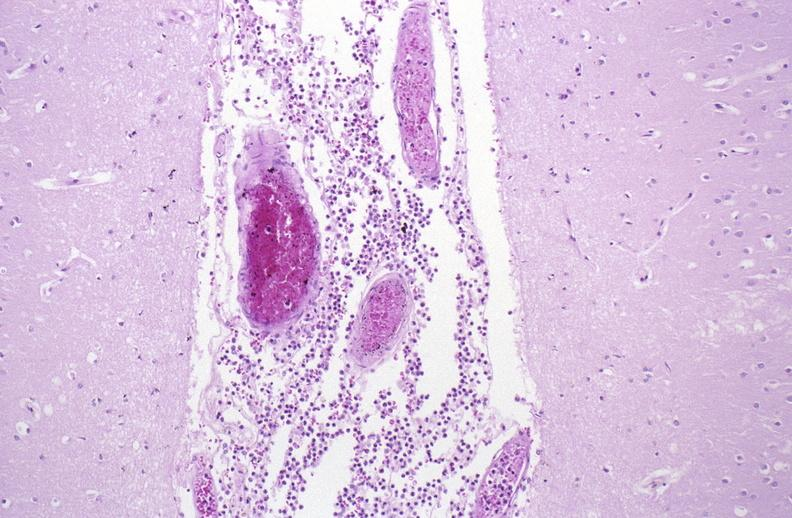where is this?
Answer the question using a single word or phrase. Nervous 